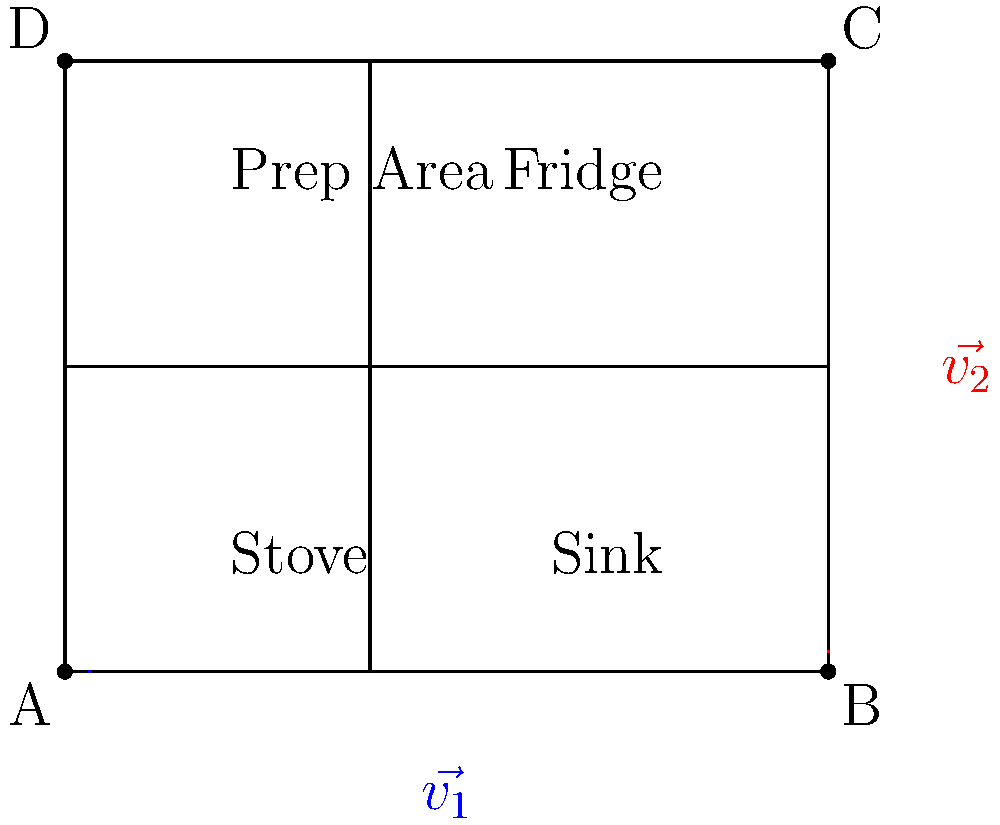In your diner's kitchen layout, appliances and work stations are represented by vectors. The stove is located at point A(0,0), and the kitchen's dimensions are given by vectors $\vec{v_1} = \langle 5, 0 \rangle$ and $\vec{v_2} = \langle 0, 4 \rangle$. If you want to place the sink at the midpoint of vector $\vec{v_1}$ and the prep area at the midpoint of the left wall, what is the vector that represents the most efficient path from the sink to the prep area? Let's approach this step-by-step:

1) The sink is at the midpoint of $\vec{v_1}$:
   Sink position = $\frac{1}{2}\vec{v_1} = \langle \frac{5}{2}, 0 \rangle$

2) The prep area is at the midpoint of the left wall:
   Left wall is represented by vector $\langle 0, 4 \rangle$
   Prep area position = $\langle 0, 2 \rangle$

3) To find the vector from sink to prep area, we subtract the sink's position from the prep area's position:
   $\vec{sink\_to\_prep} = \langle 0, 2 \rangle - \langle \frac{5}{2}, 0 \rangle$

4) Simplifying:
   $\vec{sink\_to\_prep} = \langle -\frac{5}{2}, 2 \rangle$

This vector represents the most efficient path from the sink to the prep area in the kitchen layout.
Answer: $\langle -\frac{5}{2}, 2 \rangle$ 